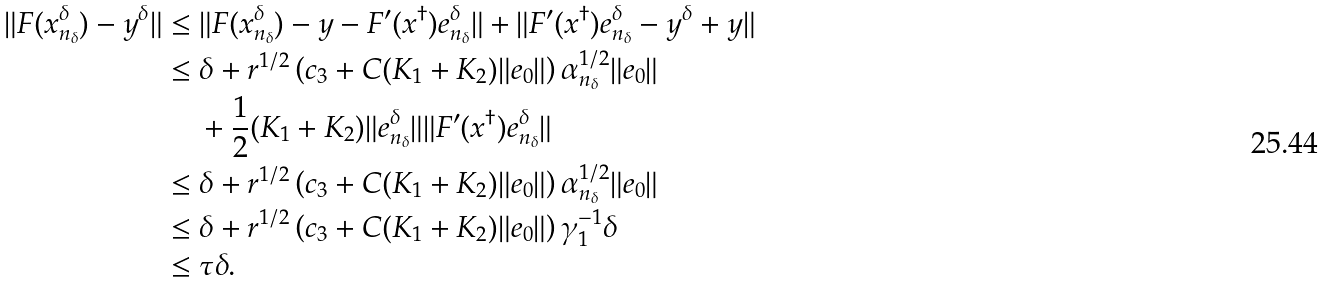Convert formula to latex. <formula><loc_0><loc_0><loc_500><loc_500>\| F ( x _ { n _ { \delta } } ^ { \delta } ) - y ^ { \delta } \| & \leq \| F ( x _ { n _ { \delta } } ^ { \delta } ) - y - F ^ { \prime } ( x ^ { \dag } ) e _ { n _ { \delta } } ^ { \delta } \| + \| F ^ { \prime } ( x ^ { \dag } ) e _ { n _ { \delta } } ^ { \delta } - y ^ { \delta } + y \| \\ & \leq \delta + r ^ { 1 / 2 } \left ( c _ { 3 } + C ( K _ { 1 } + K _ { 2 } ) \| e _ { 0 } \| \right ) \alpha _ { n _ { \delta } } ^ { 1 / 2 } \| e _ { 0 } \| \\ & \quad \, + \frac { 1 } { 2 } ( K _ { 1 } + K _ { 2 } ) \| e _ { n _ { \delta } } ^ { \delta } \| \| F ^ { \prime } ( x ^ { \dag } ) e _ { n _ { \delta } } ^ { \delta } \| \\ & \leq \delta + r ^ { 1 / 2 } \left ( c _ { 3 } + C ( K _ { 1 } + K _ { 2 } ) \| e _ { 0 } \| \right ) \alpha _ { n _ { \delta } } ^ { 1 / 2 } \| e _ { 0 } \| \\ & \leq \delta + r ^ { 1 / 2 } \left ( c _ { 3 } + C ( K _ { 1 } + K _ { 2 } ) \| e _ { 0 } \| \right ) \gamma _ { 1 } ^ { - 1 } \delta \\ & \leq \tau \delta .</formula> 